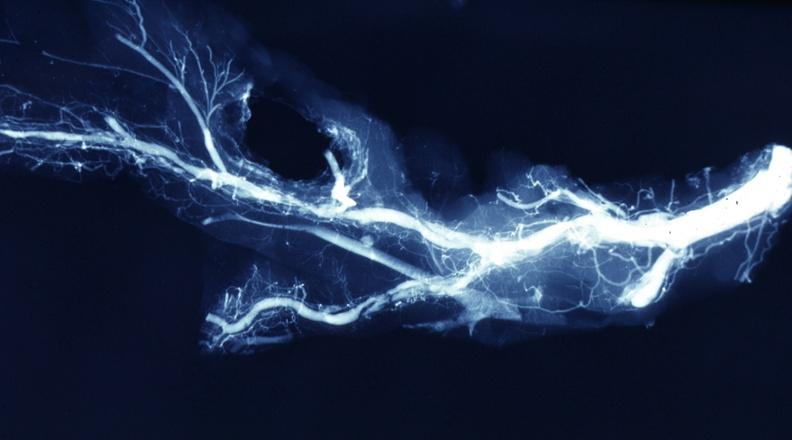what is present?
Answer the question using a single word or phrase. Vasculature 